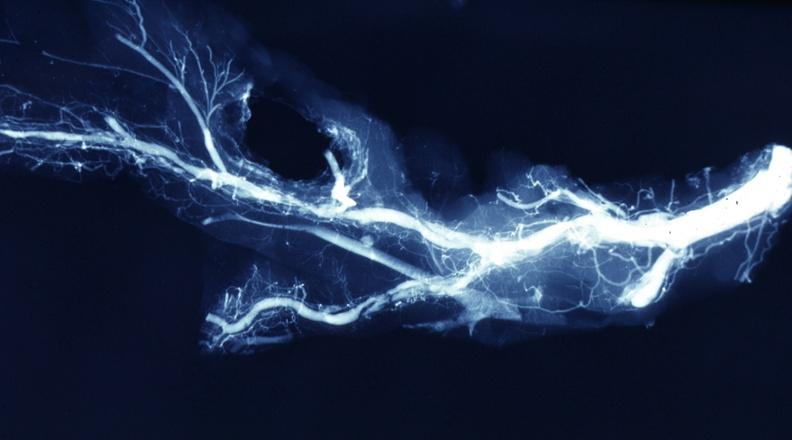what is present?
Answer the question using a single word or phrase. Vasculature 